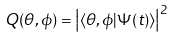<formula> <loc_0><loc_0><loc_500><loc_500>Q ( \theta , \phi ) = \left | \langle \theta , \phi | \Psi ( t ) \rangle \right | ^ { 2 }</formula> 